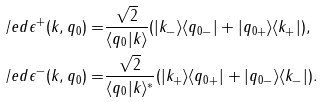<formula> <loc_0><loc_0><loc_500><loc_500>\slash e d { \epsilon } ^ { + } ( k , q _ { 0 } ) = & \frac { \sqrt { 2 } } { \langle q _ { 0 } | k \rangle } ( | k _ { - } \rangle \langle q _ { 0 - } | + | q _ { 0 + } \rangle \langle k _ { + } | ) , \\ \slash e d { \epsilon } ^ { - } ( k , q _ { 0 } ) = & \frac { \sqrt { 2 } } { \langle q _ { 0 } | k \rangle ^ { * } } ( | k _ { + } \rangle \langle q _ { 0 + } | + | q _ { 0 - } \rangle \langle k _ { - } | ) .</formula> 